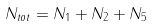<formula> <loc_0><loc_0><loc_500><loc_500>N _ { t o t } = N _ { 1 } + N _ { 2 } + N _ { 5 }</formula> 